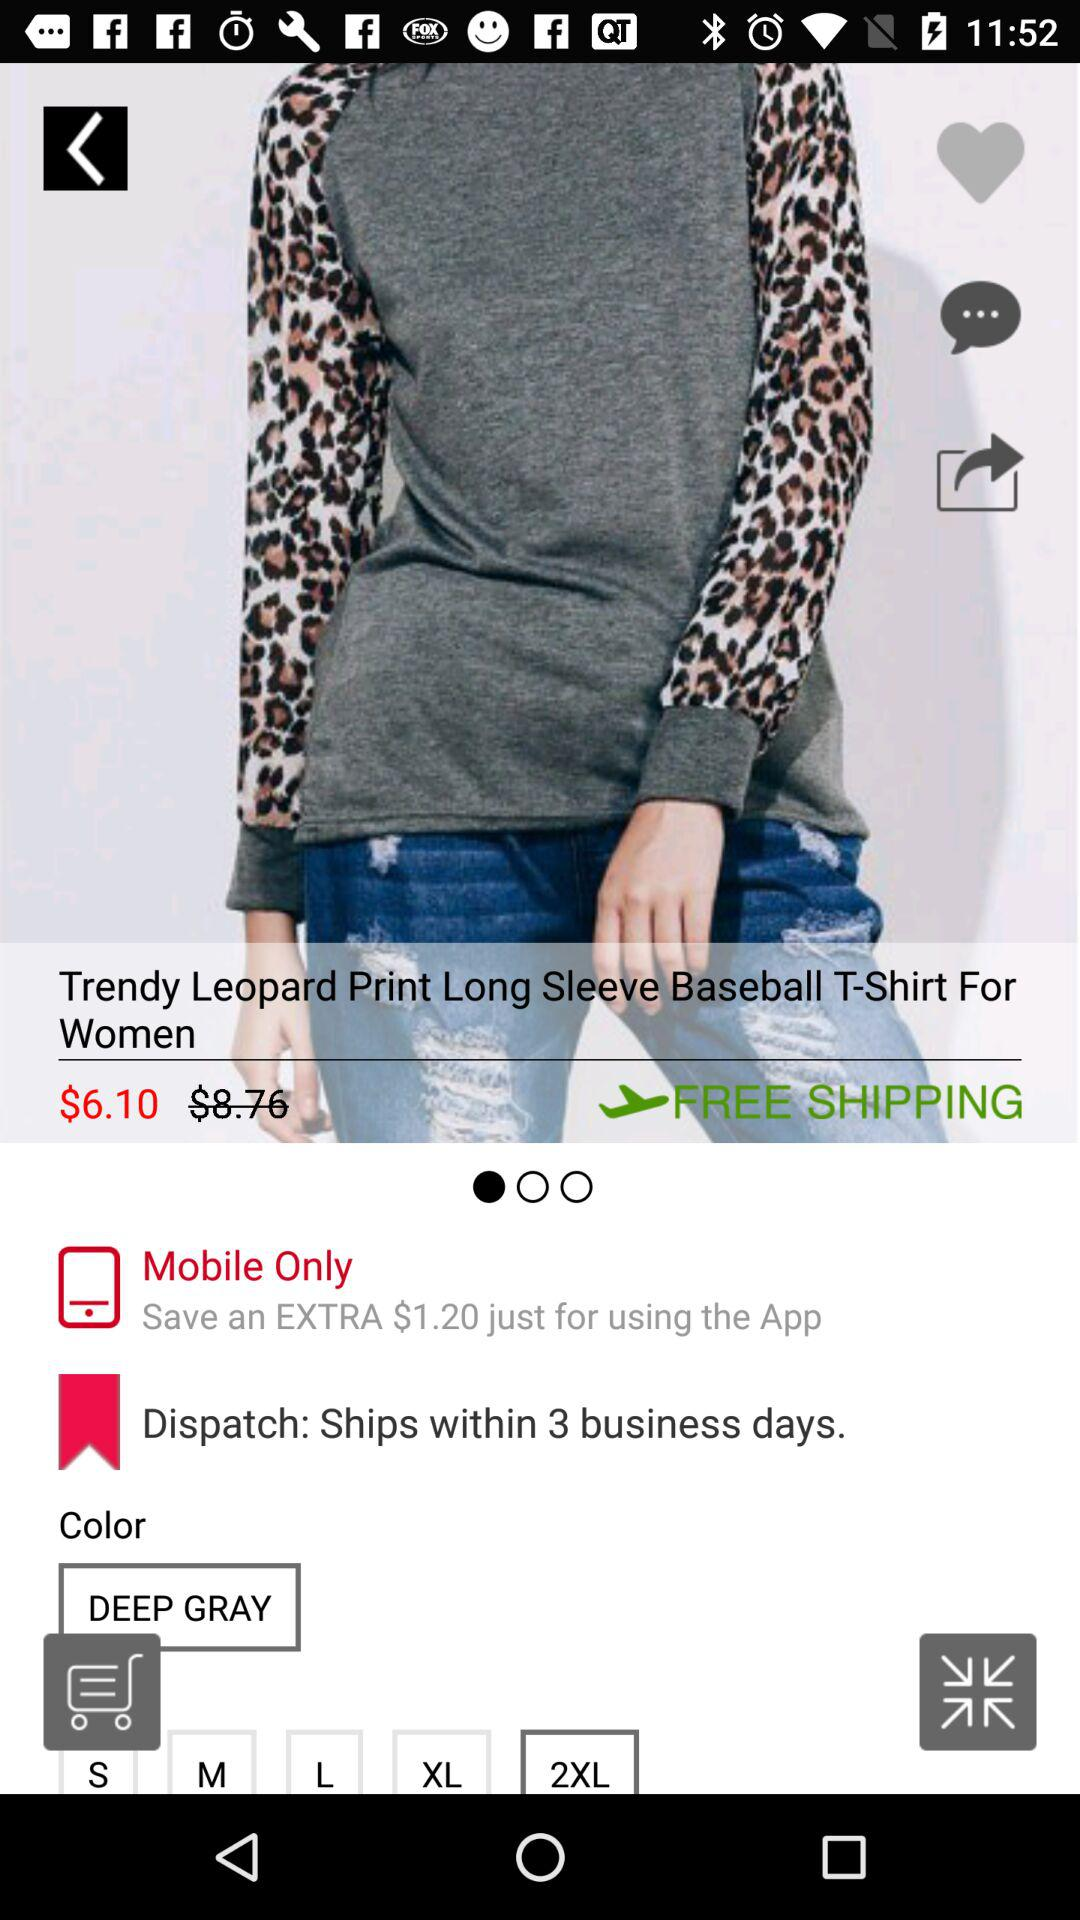What is the discounted price of the product? The discounted price of the product is $6.10. 